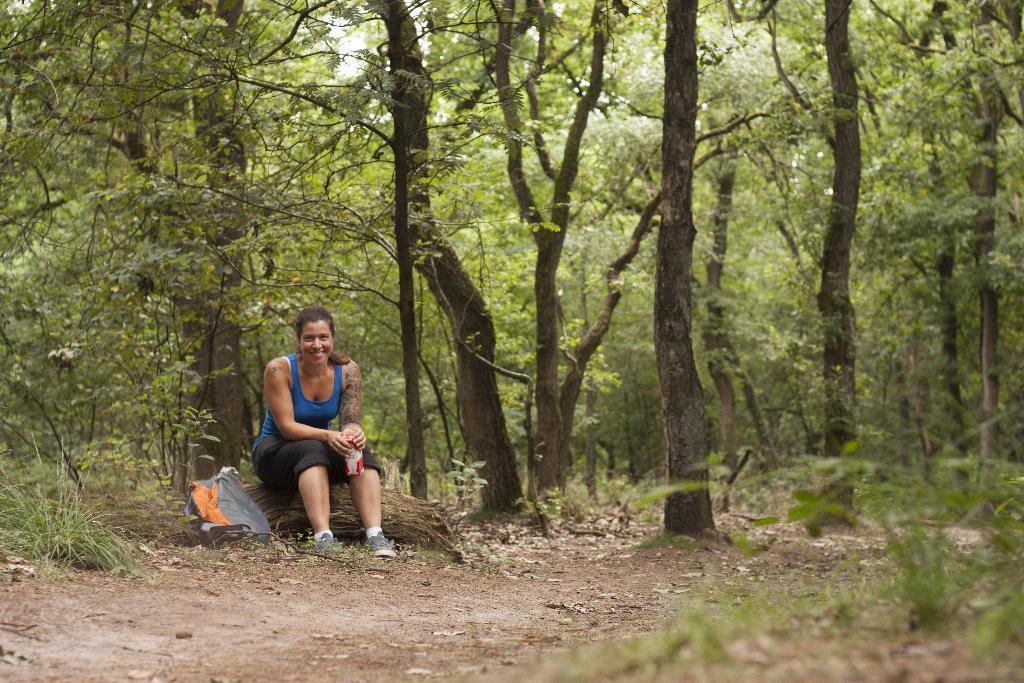In one or two sentences, can you explain what this image depicts? In this image a woman seated on the wood and she is laughing and she holds a bottle in her hands, there is a backpack near to her, in the background we can see trees. 